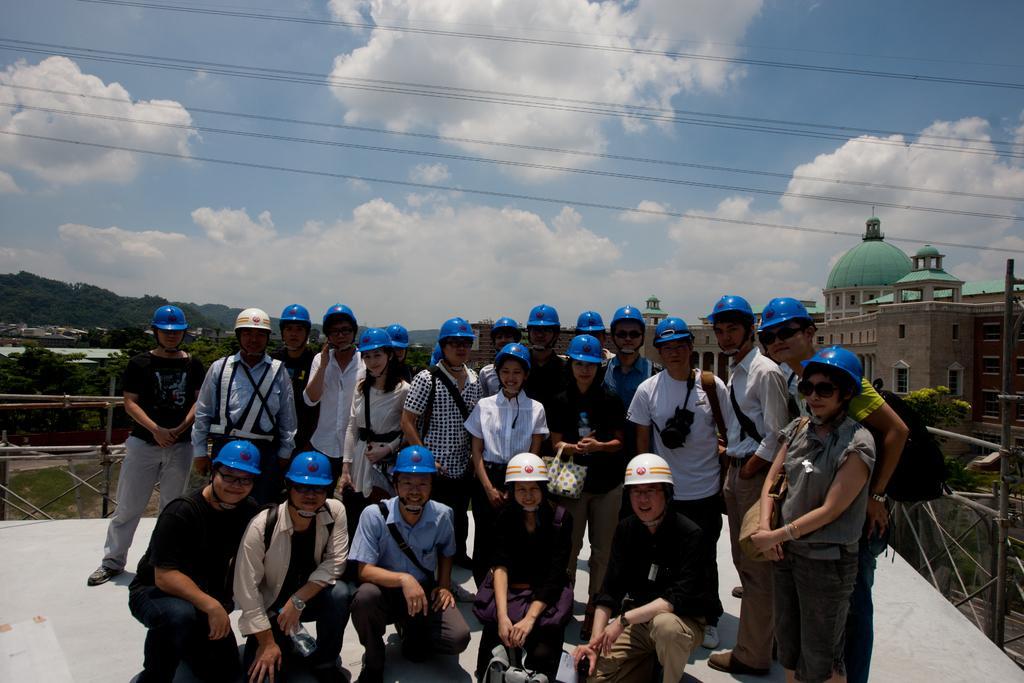Please provide a concise description of this image. In this picture there are group of people standing and smiling and there are group of people on knee. At the back there are buildings and trees and there is a railing. At the top there is sky and there are clouds and wires. At the bottom there is grass and there is a floor. 